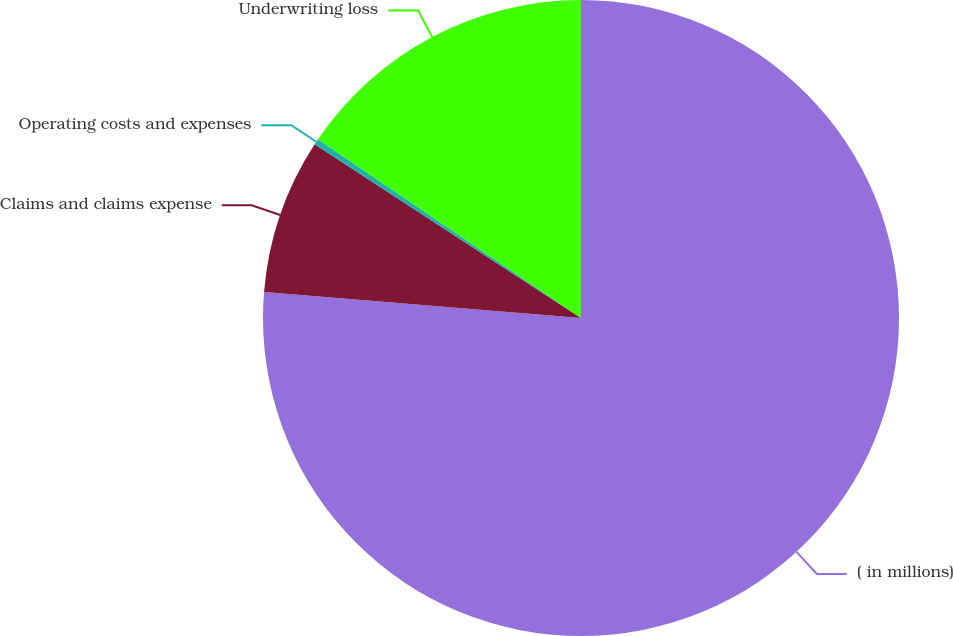<chart> <loc_0><loc_0><loc_500><loc_500><pie_chart><fcel>( in millions)<fcel>Claims and claims expense<fcel>Operating costs and expenses<fcel>Underwriting loss<nl><fcel>76.29%<fcel>7.9%<fcel>0.3%<fcel>15.5%<nl></chart> 